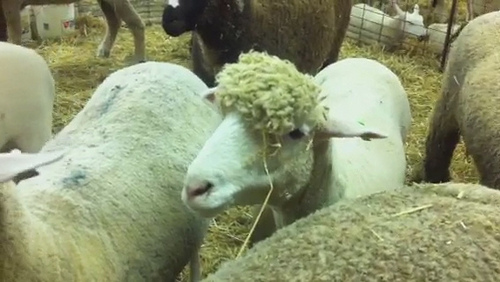Describe the environment where the sheep are located. The sheep are located in a pen with hay scattered on the ground, surrounded by a wire fence. Various other sheep are present, enhancing the sense of a communal living area. The pen has a rustic feel, likely on a farm. 